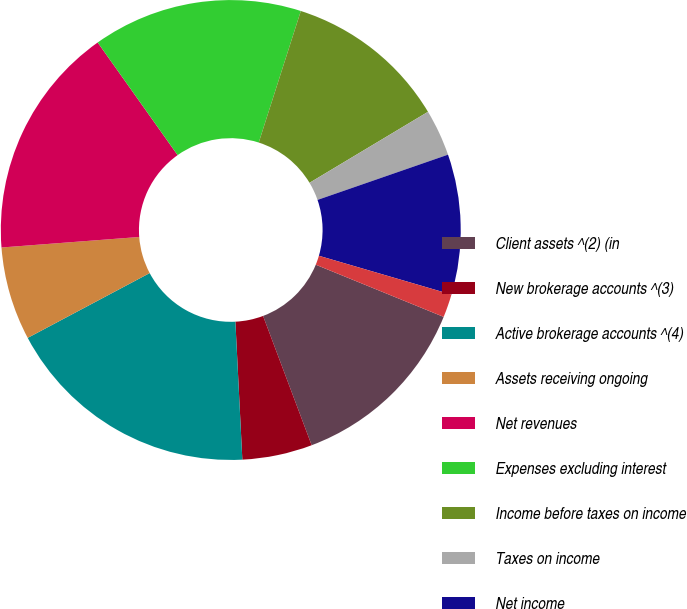<chart> <loc_0><loc_0><loc_500><loc_500><pie_chart><fcel>Client assets ^(2) (in<fcel>New brokerage accounts ^(3)<fcel>Active brokerage accounts ^(4)<fcel>Assets receiving ongoing<fcel>Net revenues<fcel>Expenses excluding interest<fcel>Income before taxes on income<fcel>Taxes on income<fcel>Net income<fcel>Preferred stock dividends<nl><fcel>13.11%<fcel>4.92%<fcel>18.03%<fcel>6.56%<fcel>16.39%<fcel>14.75%<fcel>11.48%<fcel>3.28%<fcel>9.84%<fcel>1.64%<nl></chart> 